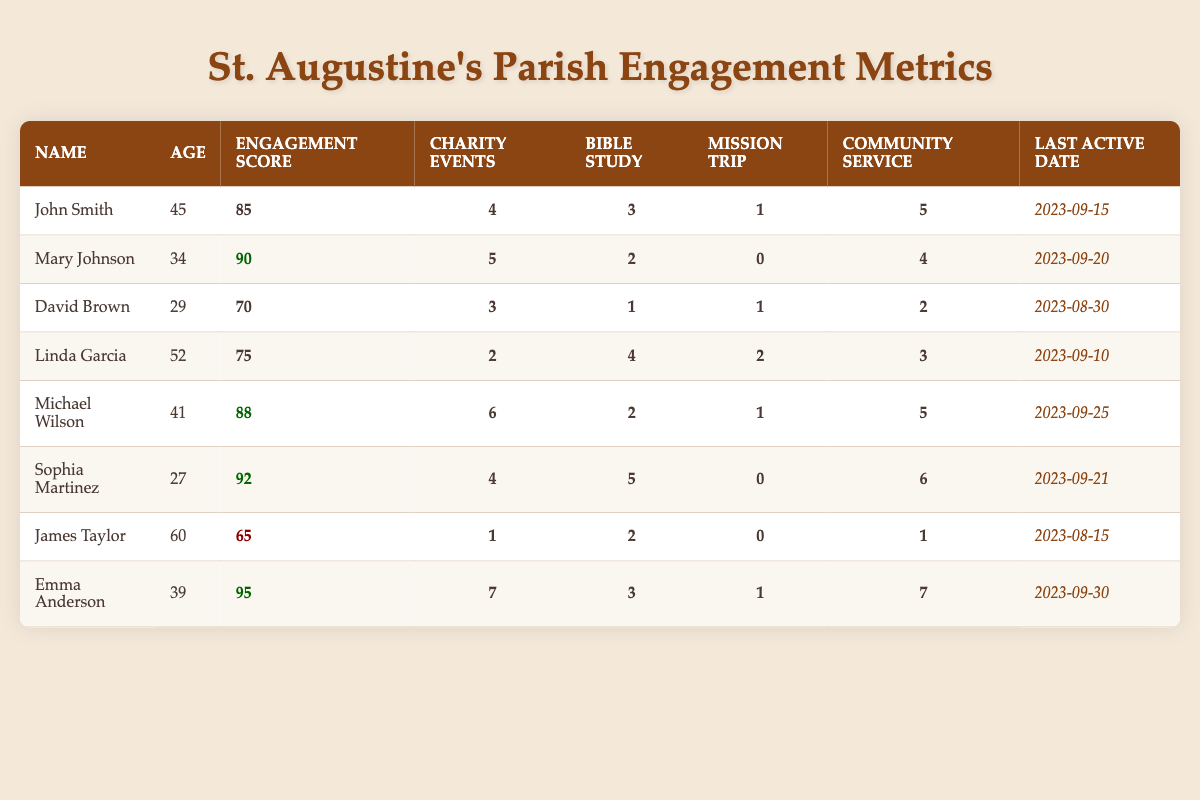What is the engagement score of Emma Anderson? Looking at the table, Emma Anderson's engagement score is explicitly listed in the "Engagement Score" column as 95.
Answer: 95 Who participated in the most community service activities? By comparing the "Community Service" column values, Emma Anderson has the highest value, which is 7.
Answer: Emma Anderson How many charity events did Michael Wilson participate in? From the table, it shows that Michael Wilson participated in 6 charity events, as indicated in the "Charity Events" column.
Answer: 6 Which parishioner has the lowest engagement score? Checking the "Engagement Score" column, James Taylor has the lowest score of 65, as seen in the table.
Answer: James Taylor What activities did Sophia Martinez not participate in? Sophia Martinez has 0 recorded for "Mission Trip" in the table, indicating she did not participate in that activity.
Answer: Mission Trip What is the average engagement score of all parishioners? First, we sum the engagement scores: 85 + 90 + 70 + 75 + 88 + 92 + 65 + 95 =  765. Dividing this by the number of parishioners (8) gives us the average: 765 / 8 = 95.625.
Answer: 95.625 Did Mary Johnson participate in a mission trip? Looking at her activities, the "Mission Trip" column contains a 0 for Mary Johnson, indicating she did not participate in one.
Answer: No What is the total number of charity events participated in by all parishioners combined? Adding the values from the "Charity Events" column: 4 + 5 + 3 + 2 + 6 + 4 + 1 + 7 = 32 gives us the total.
Answer: 32 Which parishioner had the last active date before this quarter ended? By examining the "Last Active Date" column, James Taylor's date is the earliest, being 2023-08-15.
Answer: James Taylor How many more community service activities did Emma Anderson do compared to Linda Garcia? Emma participated in 7 community service activities while Linda participated in 3. The difference is 7 - 3 = 4.
Answer: 4 